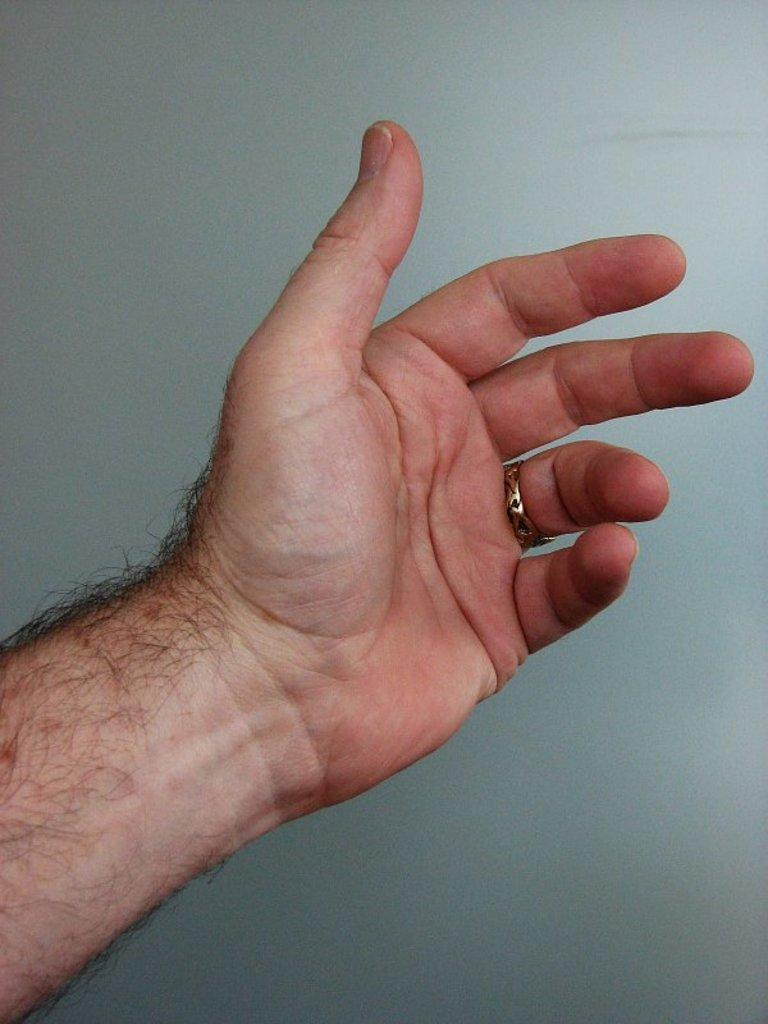What part of a person's body is visible in the image? There is a person's hand in the image. What can be seen on the palm of the hand? The hand has a visible palm. What is being held in the person's hand? There is hair in the person's hand. Is there any jewelry visible on the hand? Yes, there is a ring on a finger in the image. What type of tail can be seen on the person's daughter in the image? There is no daughter present in the image, and therefore no tail can be seen. 